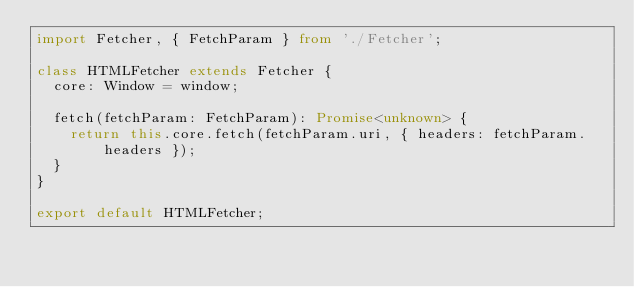<code> <loc_0><loc_0><loc_500><loc_500><_TypeScript_>import Fetcher, { FetchParam } from './Fetcher';

class HTMLFetcher extends Fetcher {
  core: Window = window;

  fetch(fetchParam: FetchParam): Promise<unknown> {
    return this.core.fetch(fetchParam.uri, { headers: fetchParam.headers });
  }
}

export default HTMLFetcher;
</code> 